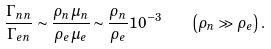Convert formula to latex. <formula><loc_0><loc_0><loc_500><loc_500>\frac { \Gamma _ { n n } } { \Gamma _ { e n } } \sim \frac { \rho _ { n } \mu _ { n } } { \rho _ { e } \mu _ { e } } \sim \frac { \rho _ { n } } { \rho _ { e } } 1 0 ^ { - 3 } \quad \left ( \rho _ { n } \gg \rho _ { e } \right ) .</formula> 